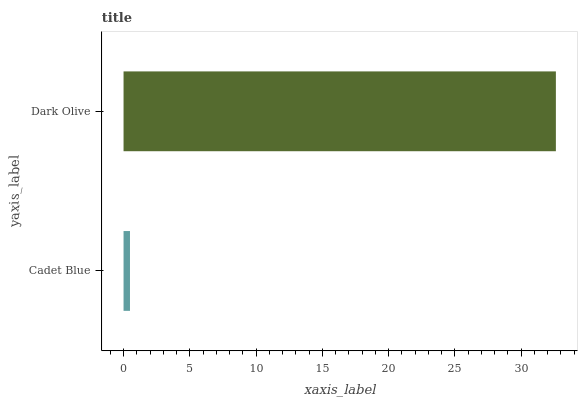Is Cadet Blue the minimum?
Answer yes or no. Yes. Is Dark Olive the maximum?
Answer yes or no. Yes. Is Dark Olive the minimum?
Answer yes or no. No. Is Dark Olive greater than Cadet Blue?
Answer yes or no. Yes. Is Cadet Blue less than Dark Olive?
Answer yes or no. Yes. Is Cadet Blue greater than Dark Olive?
Answer yes or no. No. Is Dark Olive less than Cadet Blue?
Answer yes or no. No. Is Dark Olive the high median?
Answer yes or no. Yes. Is Cadet Blue the low median?
Answer yes or no. Yes. Is Cadet Blue the high median?
Answer yes or no. No. Is Dark Olive the low median?
Answer yes or no. No. 